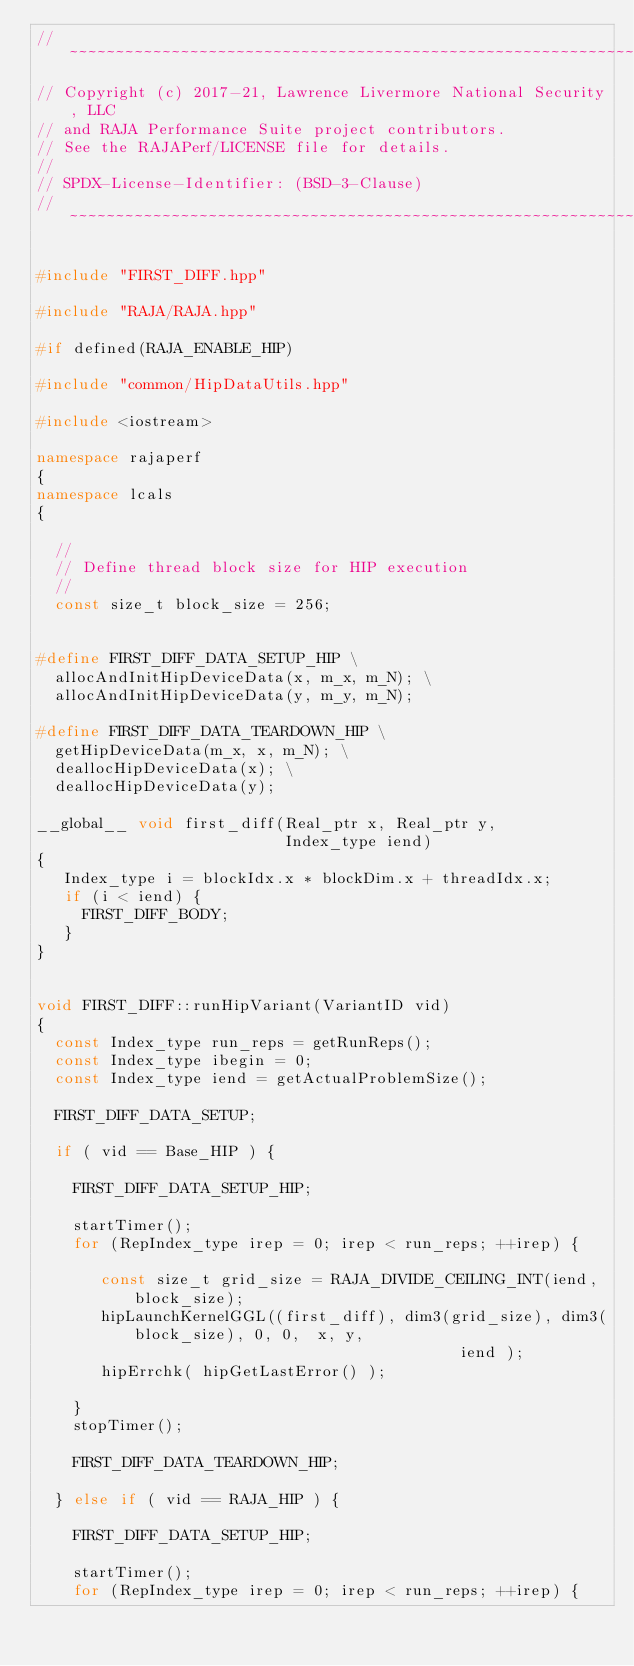<code> <loc_0><loc_0><loc_500><loc_500><_C++_>//~~~~~~~~~~~~~~~~~~~~~~~~~~~~~~~~~~~~~~~~~~~~~~~~~~~~~~~~~~~~~~~~~~~~~~~~~~~//
// Copyright (c) 2017-21, Lawrence Livermore National Security, LLC
// and RAJA Performance Suite project contributors.
// See the RAJAPerf/LICENSE file for details.
//
// SPDX-License-Identifier: (BSD-3-Clause)
//~~~~~~~~~~~~~~~~~~~~~~~~~~~~~~~~~~~~~~~~~~~~~~~~~~~~~~~~~~~~~~~~~~~~~~~~~~~//

#include "FIRST_DIFF.hpp"

#include "RAJA/RAJA.hpp"

#if defined(RAJA_ENABLE_HIP)

#include "common/HipDataUtils.hpp"

#include <iostream>

namespace rajaperf
{
namespace lcals
{

  //
  // Define thread block size for HIP execution
  //
  const size_t block_size = 256;


#define FIRST_DIFF_DATA_SETUP_HIP \
  allocAndInitHipDeviceData(x, m_x, m_N); \
  allocAndInitHipDeviceData(y, m_y, m_N);

#define FIRST_DIFF_DATA_TEARDOWN_HIP \
  getHipDeviceData(m_x, x, m_N); \
  deallocHipDeviceData(x); \
  deallocHipDeviceData(y);

__global__ void first_diff(Real_ptr x, Real_ptr y,
                           Index_type iend)
{
   Index_type i = blockIdx.x * blockDim.x + threadIdx.x;
   if (i < iend) {
     FIRST_DIFF_BODY;
   }
}


void FIRST_DIFF::runHipVariant(VariantID vid)
{
  const Index_type run_reps = getRunReps();
  const Index_type ibegin = 0;
  const Index_type iend = getActualProblemSize();

  FIRST_DIFF_DATA_SETUP;

  if ( vid == Base_HIP ) {

    FIRST_DIFF_DATA_SETUP_HIP;

    startTimer();
    for (RepIndex_type irep = 0; irep < run_reps; ++irep) {

       const size_t grid_size = RAJA_DIVIDE_CEILING_INT(iend, block_size);
       hipLaunchKernelGGL((first_diff), dim3(grid_size), dim3(block_size), 0, 0,  x, y,
                                              iend );
       hipErrchk( hipGetLastError() );

    }
    stopTimer();

    FIRST_DIFF_DATA_TEARDOWN_HIP;

  } else if ( vid == RAJA_HIP ) {

    FIRST_DIFF_DATA_SETUP_HIP;

    startTimer();
    for (RepIndex_type irep = 0; irep < run_reps; ++irep) {
</code> 